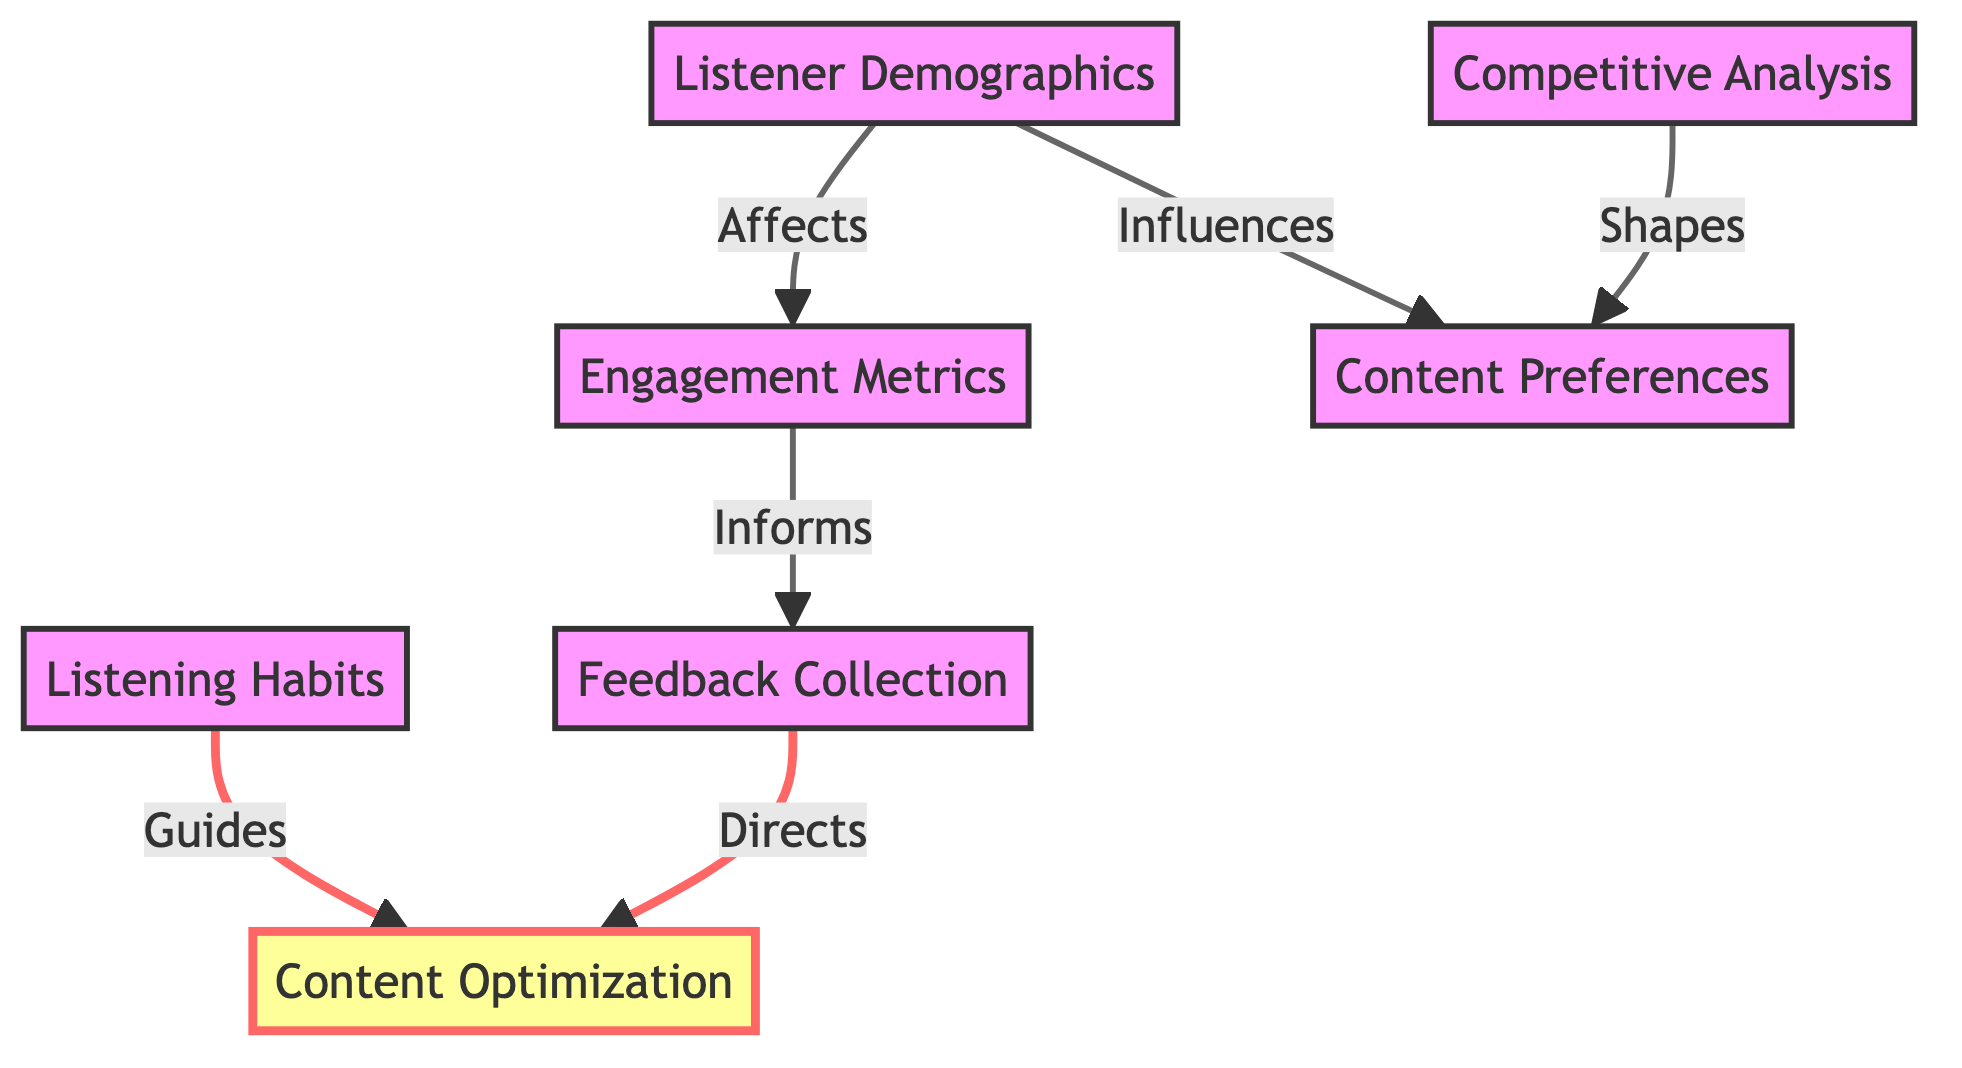What are the total number of nodes in the diagram? The diagram lists seven distinct nodes: Listener Demographics, Engagement Metrics, Content Preferences, Listening Habits, Feedback Collection, Competitive Analysis, and Content Optimization. Counting these nodes gives us a total of 7.
Answer: 7 Which node is influenced by Listener Demographics? Based on the directed edges in the diagram, Listener Demographics influences Content Preferences and Engagement Metrics. This indicates that both nodes are affected by the information pertaining to listener demographics.
Answer: Content Preferences, Engagement Metrics What relationship does Engagement Metrics have with Feedback Collection? The directed edge from Engagement Metrics to Feedback Collection signifies that Engagement Metrics informs or is a source for Feedback Collection. This means that evaluating listener interactions plays a role in gathering listener insights.
Answer: Informs How many edges are present in the diagram? The directed graph contains six directed edges connecting the nodes. They represent the relationships influencing each other as shown in the diagram. Counting these edges provides a total of 6.
Answer: 6 Which two nodes are connected by the edge that directs to Content Optimization? The diagram shows two directed edges leading to the node Content Optimization: one from Listening Habits and another from Feedback Collection. This indicates that both sources guide the content optimization process.
Answer: Listening Habits, Feedback Collection What kind of analysis involves reviewing successful podcasts in the same niche? The directed edge from Competitive Analysis directs to Content Preferences, indicating that the analysis of competitors shapes content preferences. This emphasizes that understanding competitors can influence what topics resonate with the audience.
Answer: Competitive Analysis What is the main focus of Content Optimization? The node Content Optimization is focused on adjusting future episodes based on insights gathered from various data points such as listener demographics, feedback collection, and engagement metrics. This indicates the goal of enhancing listener satisfaction based on the analysis.
Answer: Enhance listener satisfaction 